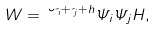Convert formula to latex. <formula><loc_0><loc_0><loc_500><loc_500>W = \lambda ^ { \psi _ { i } + \psi _ { j } + h } \Psi _ { i } \Psi _ { j } H ,</formula> 